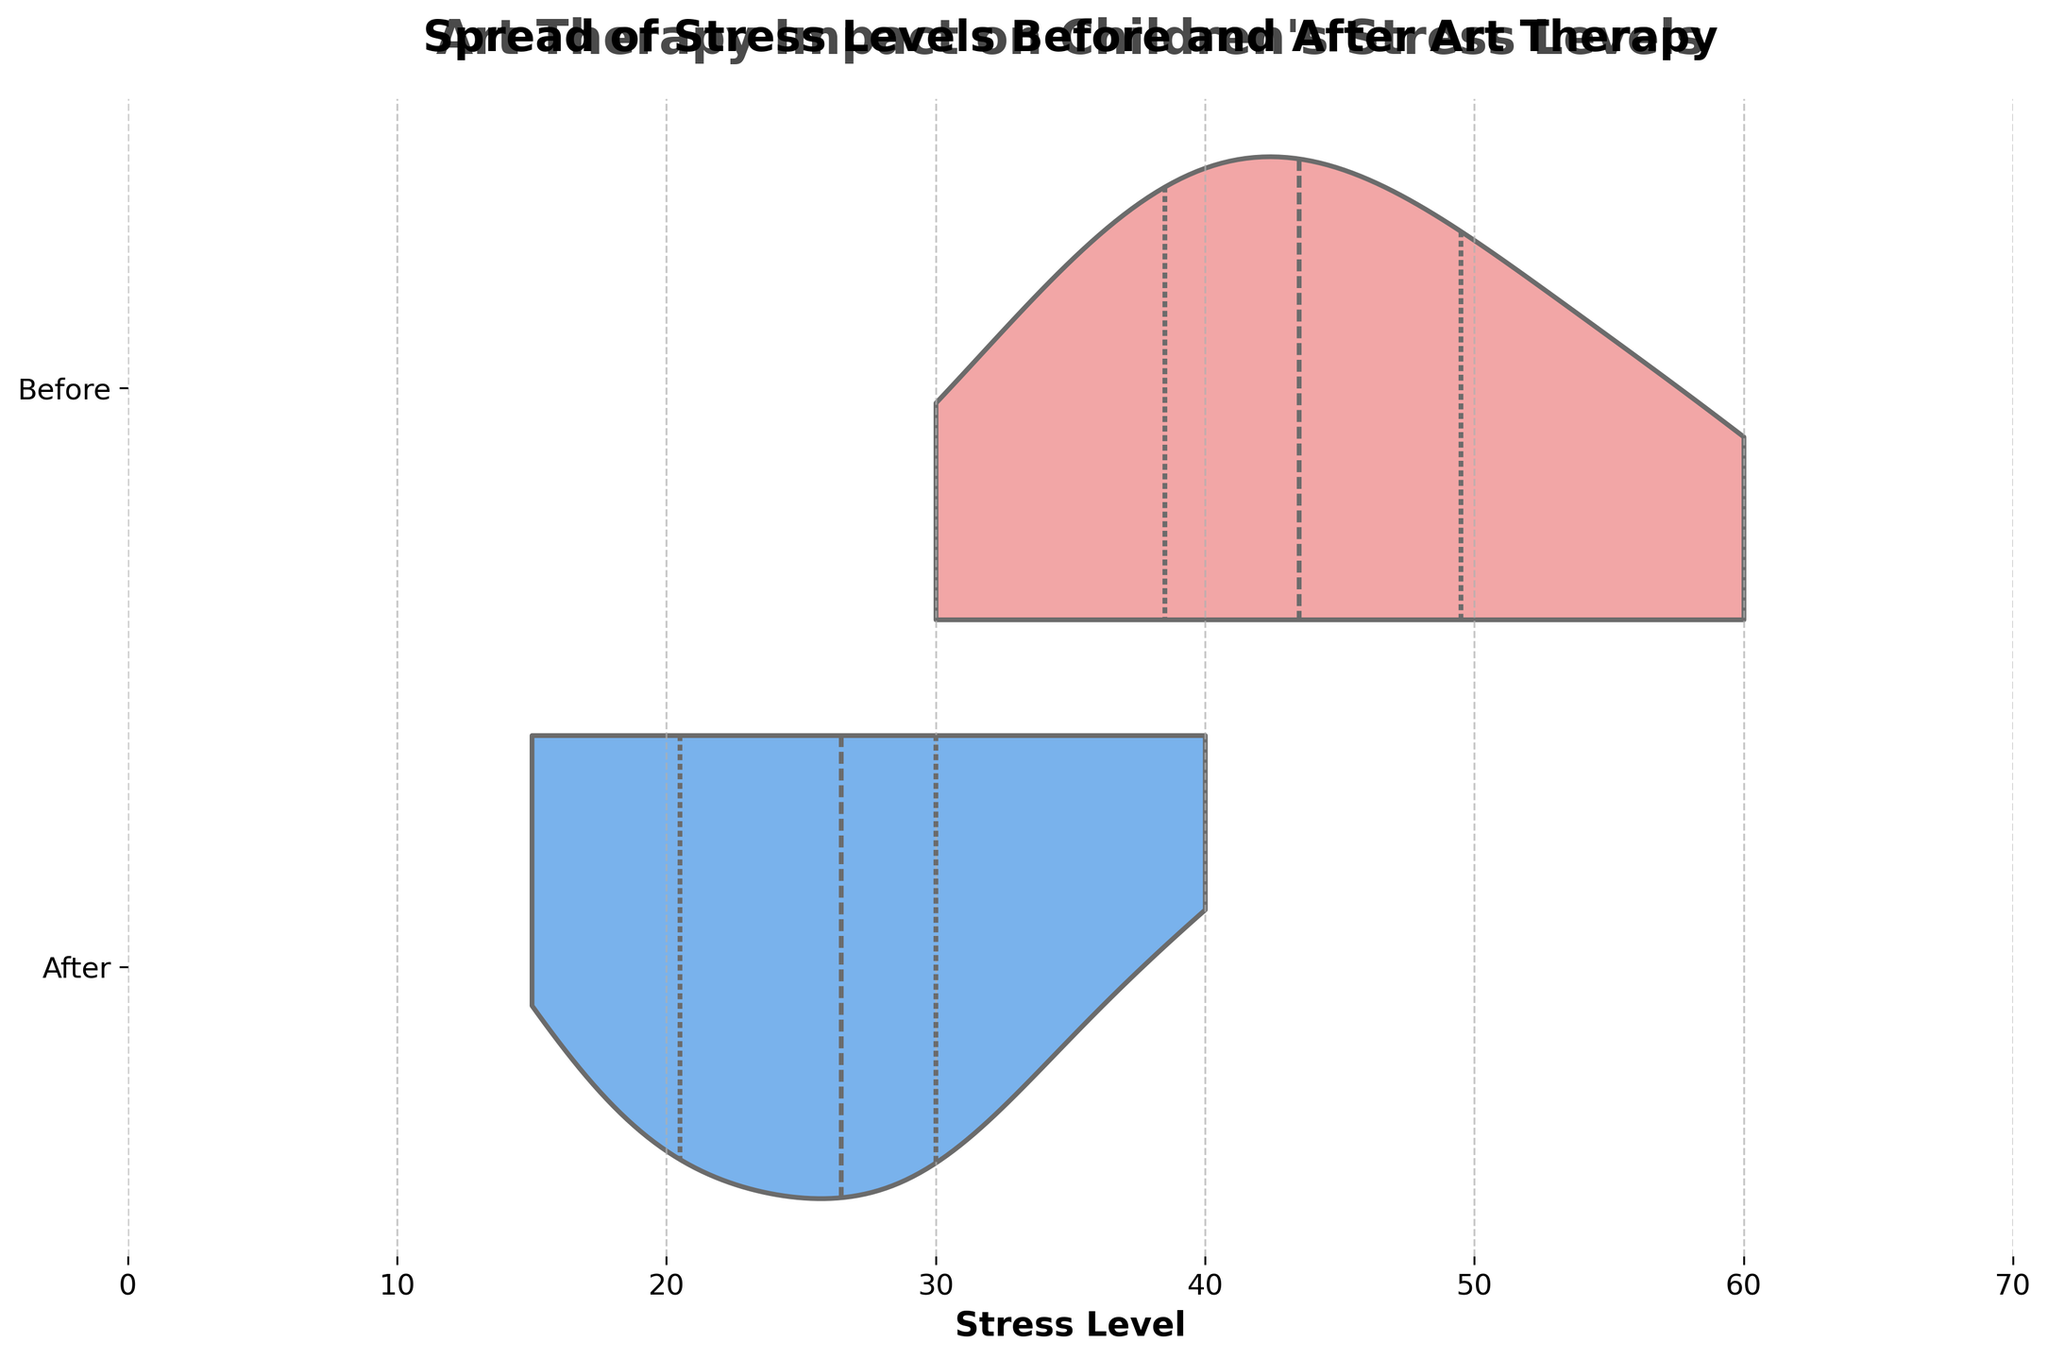What is the title of the chart? The title is written at the top of the chart and reads 'Spread of Stress Levels Before and After Art Therapy'.
Answer: Spread of Stress Levels Before and After Art Therapy How many time periods are compared in the chart? The y-axis shows two time periods labeled 'Before' and 'After', indicating that stress levels before and after art therapy are compared.
Answer: 2 Which time period shows a wider distribution of stress levels? By observing the width of the horizontal violins, the 'Before' art therapy session shows a wider distribution compared to the 'After' session.
Answer: Before Are stress levels generally lower after the art therapy sessions? The violins for 'After' therapy sessions are shifted to the left (lower stress levels) compared to 'Before' therapy sessions, indicating that stress levels are generally lower after the sessions.
Answer: Yes What is the maximum stress level recorded before the art therapy sessions? The maximum value on the horizontal axis in the 'Before' violin plot touches around 60, indicating the maximum stress level before therapy.
Answer: 60 What is the median stress level after the art therapy sessions? The 'After' violin has a line inside the violin plotting the median, which is roughly at 25, indicating the median stress level after the sessions.
Answer: 25 How do the interquartile ranges compare before and after art therapy? The thick parts of the violins (representing the interquartile range) are wider in the 'Before' session compared to the 'After' session, indicating a larger interquartile range for stress levels before therapy.
Answer: Before has a larger IQR What is the difference between the median stress levels before and after art therapy? The median stress level is approximately 42 before and 25 after art therapy. The difference is 42 - 25.
Answer: 17 Is there any overlap in stress levels before and after art therapy? By looking at the violin plots, there is some overlap in the tails of the two distributions, indicating that some stress levels are similar before and after.
Answer: Yes Which period has the smaller range of stress levels? The 'After' violin plot is more compressed horizontally compared to the 'Before' plot, indicating a smaller range of stress levels after therapy.
Answer: After 